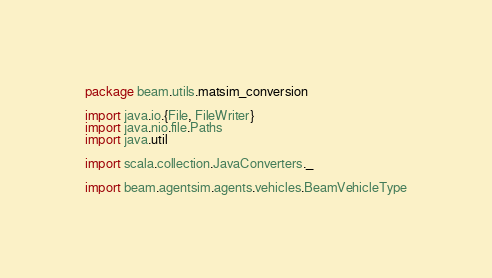Convert code to text. <code><loc_0><loc_0><loc_500><loc_500><_Scala_>package beam.utils.matsim_conversion

import java.io.{File, FileWriter}
import java.nio.file.Paths
import java.util

import scala.collection.JavaConverters._

import beam.agentsim.agents.vehicles.BeamVehicleType</code> 